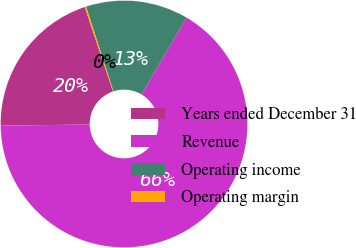Convert chart. <chart><loc_0><loc_0><loc_500><loc_500><pie_chart><fcel>Years ended December 31<fcel>Revenue<fcel>Operating income<fcel>Operating margin<nl><fcel>20.06%<fcel>66.31%<fcel>13.45%<fcel>0.18%<nl></chart> 